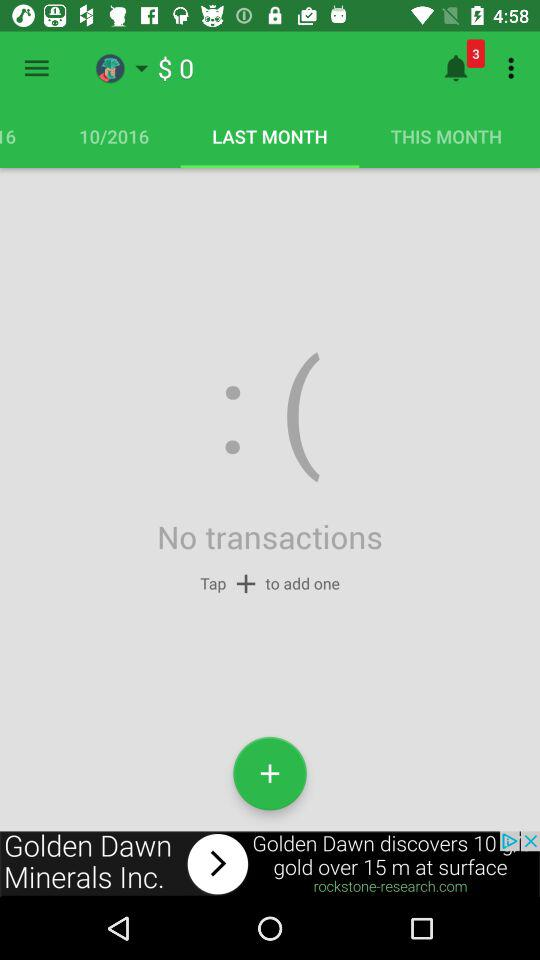How much money was spent in total?
Answer the question using a single word or phrase. $0 